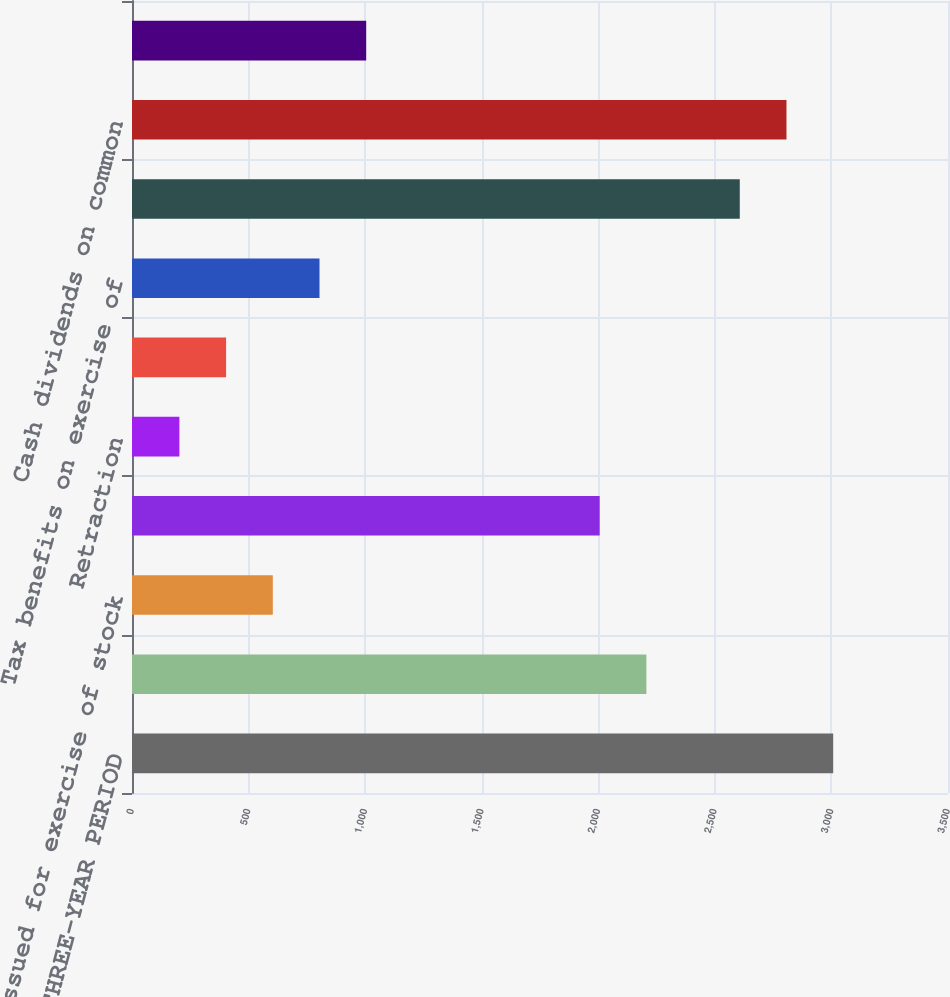Convert chart to OTSL. <chart><loc_0><loc_0><loc_500><loc_500><bar_chart><fcel>FOR THE THREE-YEAR PERIOD<fcel>Balance at beginning of year<fcel>Issued for exercise of stock<fcel>Balance at end of year<fcel>Retraction<fcel>Issued in retraction of<fcel>Tax benefits on exercise of<fcel>Net earnings<fcel>Cash dividends on common<fcel>Foreign currency translation<nl><fcel>3007.5<fcel>2206.3<fcel>603.9<fcel>2006<fcel>203.3<fcel>403.6<fcel>804.2<fcel>2606.9<fcel>2807.2<fcel>1004.5<nl></chart> 